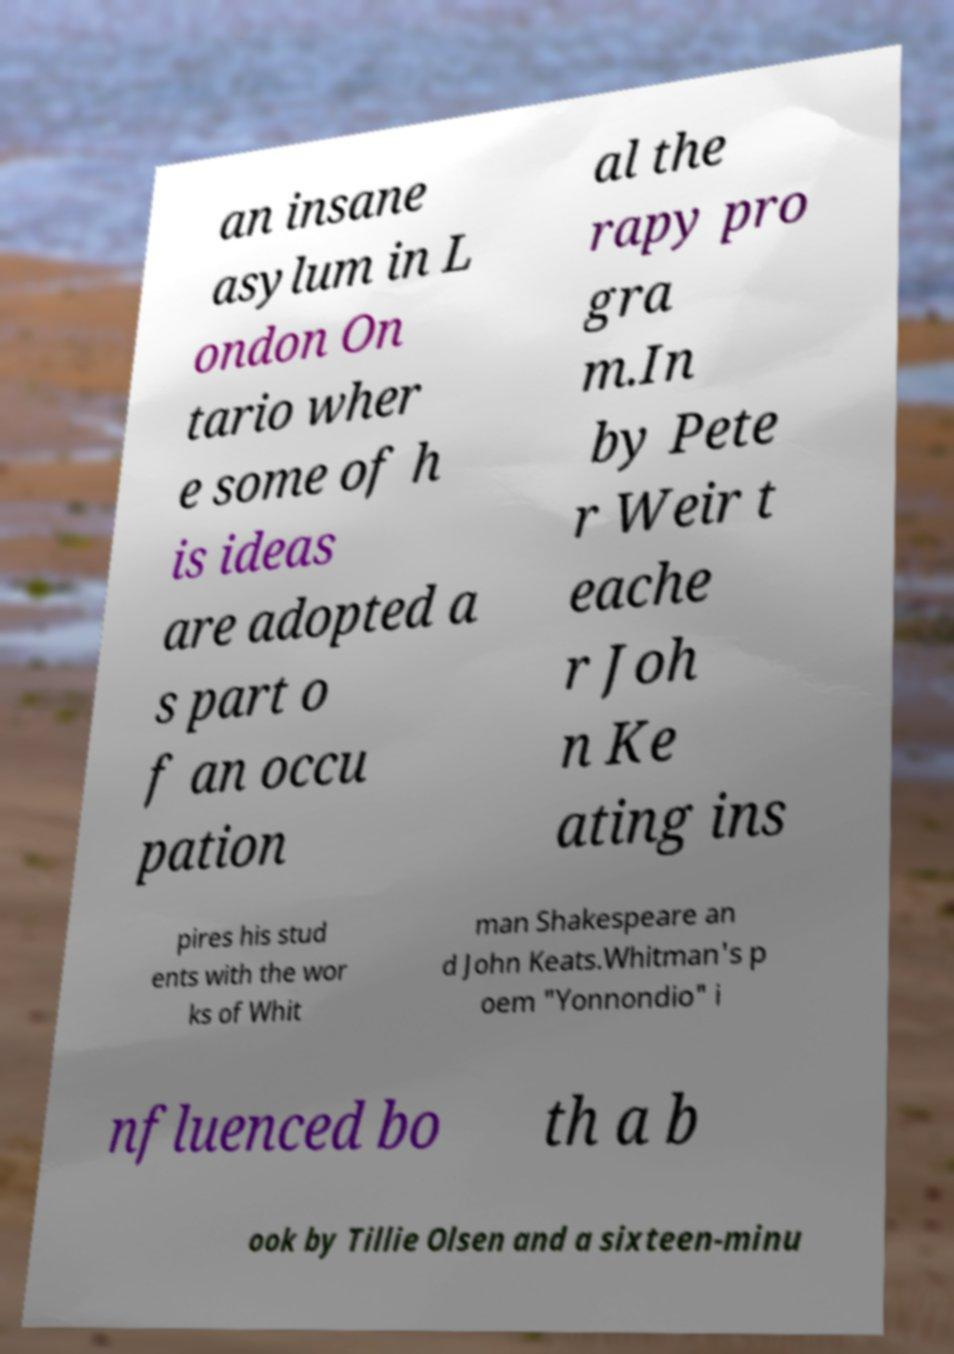Please read and relay the text visible in this image. What does it say? an insane asylum in L ondon On tario wher e some of h is ideas are adopted a s part o f an occu pation al the rapy pro gra m.In by Pete r Weir t eache r Joh n Ke ating ins pires his stud ents with the wor ks of Whit man Shakespeare an d John Keats.Whitman's p oem "Yonnondio" i nfluenced bo th a b ook by Tillie Olsen and a sixteen-minu 